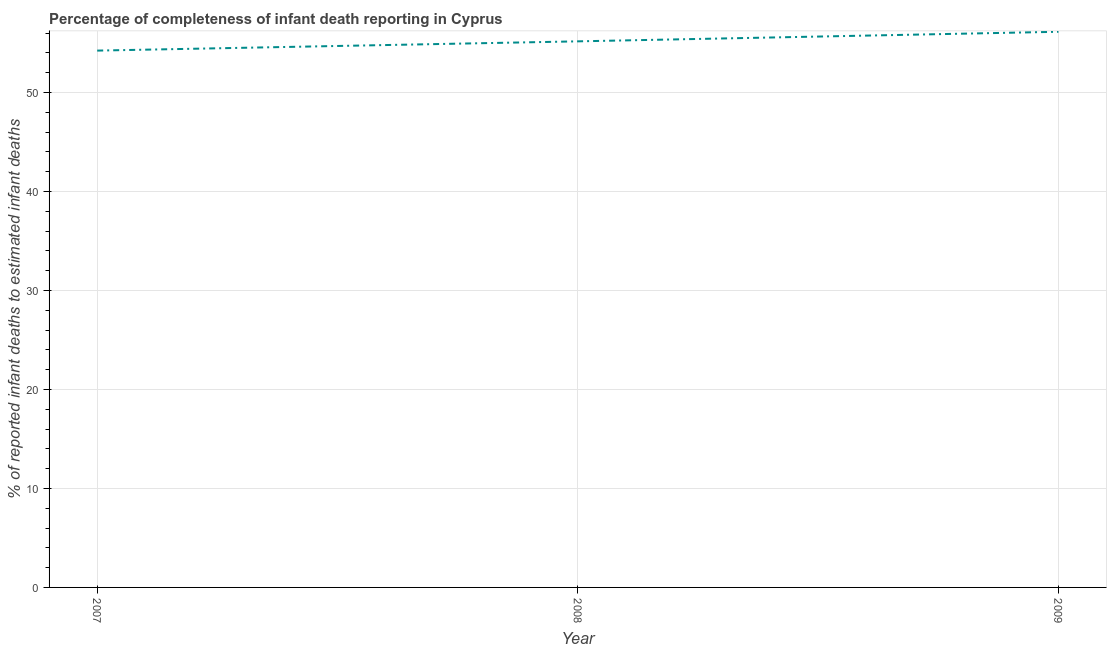What is the completeness of infant death reporting in 2007?
Provide a short and direct response. 54.24. Across all years, what is the maximum completeness of infant death reporting?
Give a very brief answer. 56.14. Across all years, what is the minimum completeness of infant death reporting?
Give a very brief answer. 54.24. In which year was the completeness of infant death reporting maximum?
Give a very brief answer. 2009. What is the sum of the completeness of infant death reporting?
Your answer should be very brief. 165.55. What is the difference between the completeness of infant death reporting in 2007 and 2008?
Provide a succinct answer. -0.94. What is the average completeness of infant death reporting per year?
Offer a very short reply. 55.18. What is the median completeness of infant death reporting?
Provide a succinct answer. 55.17. What is the ratio of the completeness of infant death reporting in 2007 to that in 2008?
Offer a terse response. 0.98. Is the completeness of infant death reporting in 2007 less than that in 2008?
Provide a succinct answer. Yes. What is the difference between the highest and the second highest completeness of infant death reporting?
Your answer should be very brief. 0.97. Is the sum of the completeness of infant death reporting in 2008 and 2009 greater than the maximum completeness of infant death reporting across all years?
Provide a succinct answer. Yes. What is the difference between the highest and the lowest completeness of infant death reporting?
Offer a terse response. 1.9. In how many years, is the completeness of infant death reporting greater than the average completeness of infant death reporting taken over all years?
Offer a very short reply. 1. Does the completeness of infant death reporting monotonically increase over the years?
Your answer should be very brief. Yes. How many years are there in the graph?
Make the answer very short. 3. Are the values on the major ticks of Y-axis written in scientific E-notation?
Keep it short and to the point. No. Does the graph contain grids?
Make the answer very short. Yes. What is the title of the graph?
Provide a short and direct response. Percentage of completeness of infant death reporting in Cyprus. What is the label or title of the X-axis?
Ensure brevity in your answer.  Year. What is the label or title of the Y-axis?
Offer a very short reply. % of reported infant deaths to estimated infant deaths. What is the % of reported infant deaths to estimated infant deaths of 2007?
Offer a very short reply. 54.24. What is the % of reported infant deaths to estimated infant deaths of 2008?
Your answer should be compact. 55.17. What is the % of reported infant deaths to estimated infant deaths in 2009?
Your answer should be compact. 56.14. What is the difference between the % of reported infant deaths to estimated infant deaths in 2007 and 2008?
Your answer should be compact. -0.94. What is the difference between the % of reported infant deaths to estimated infant deaths in 2007 and 2009?
Provide a short and direct response. -1.9. What is the difference between the % of reported infant deaths to estimated infant deaths in 2008 and 2009?
Offer a very short reply. -0.97. 